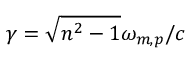<formula> <loc_0><loc_0><loc_500><loc_500>\gamma = \sqrt { n ^ { 2 } - 1 } \omega _ { m , p } / c</formula> 